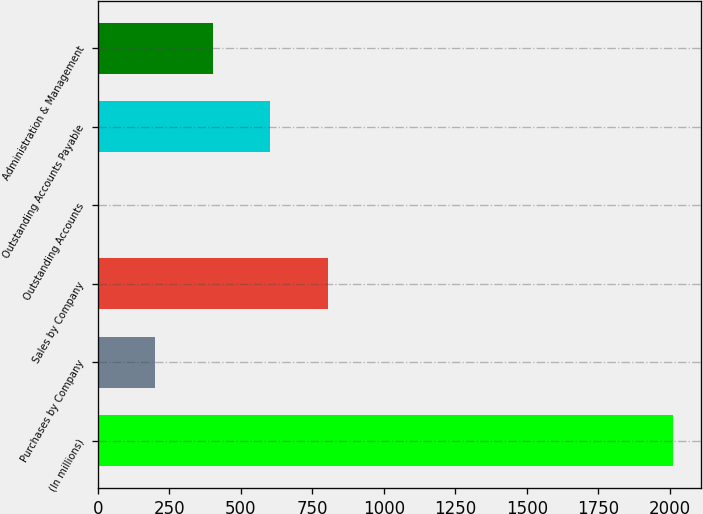Convert chart to OTSL. <chart><loc_0><loc_0><loc_500><loc_500><bar_chart><fcel>(In millions)<fcel>Purchases by Company<fcel>Sales by Company<fcel>Outstanding Accounts<fcel>Outstanding Accounts Payable<fcel>Administration & Management<nl><fcel>2010<fcel>201.45<fcel>804.3<fcel>0.5<fcel>603.35<fcel>402.4<nl></chart> 